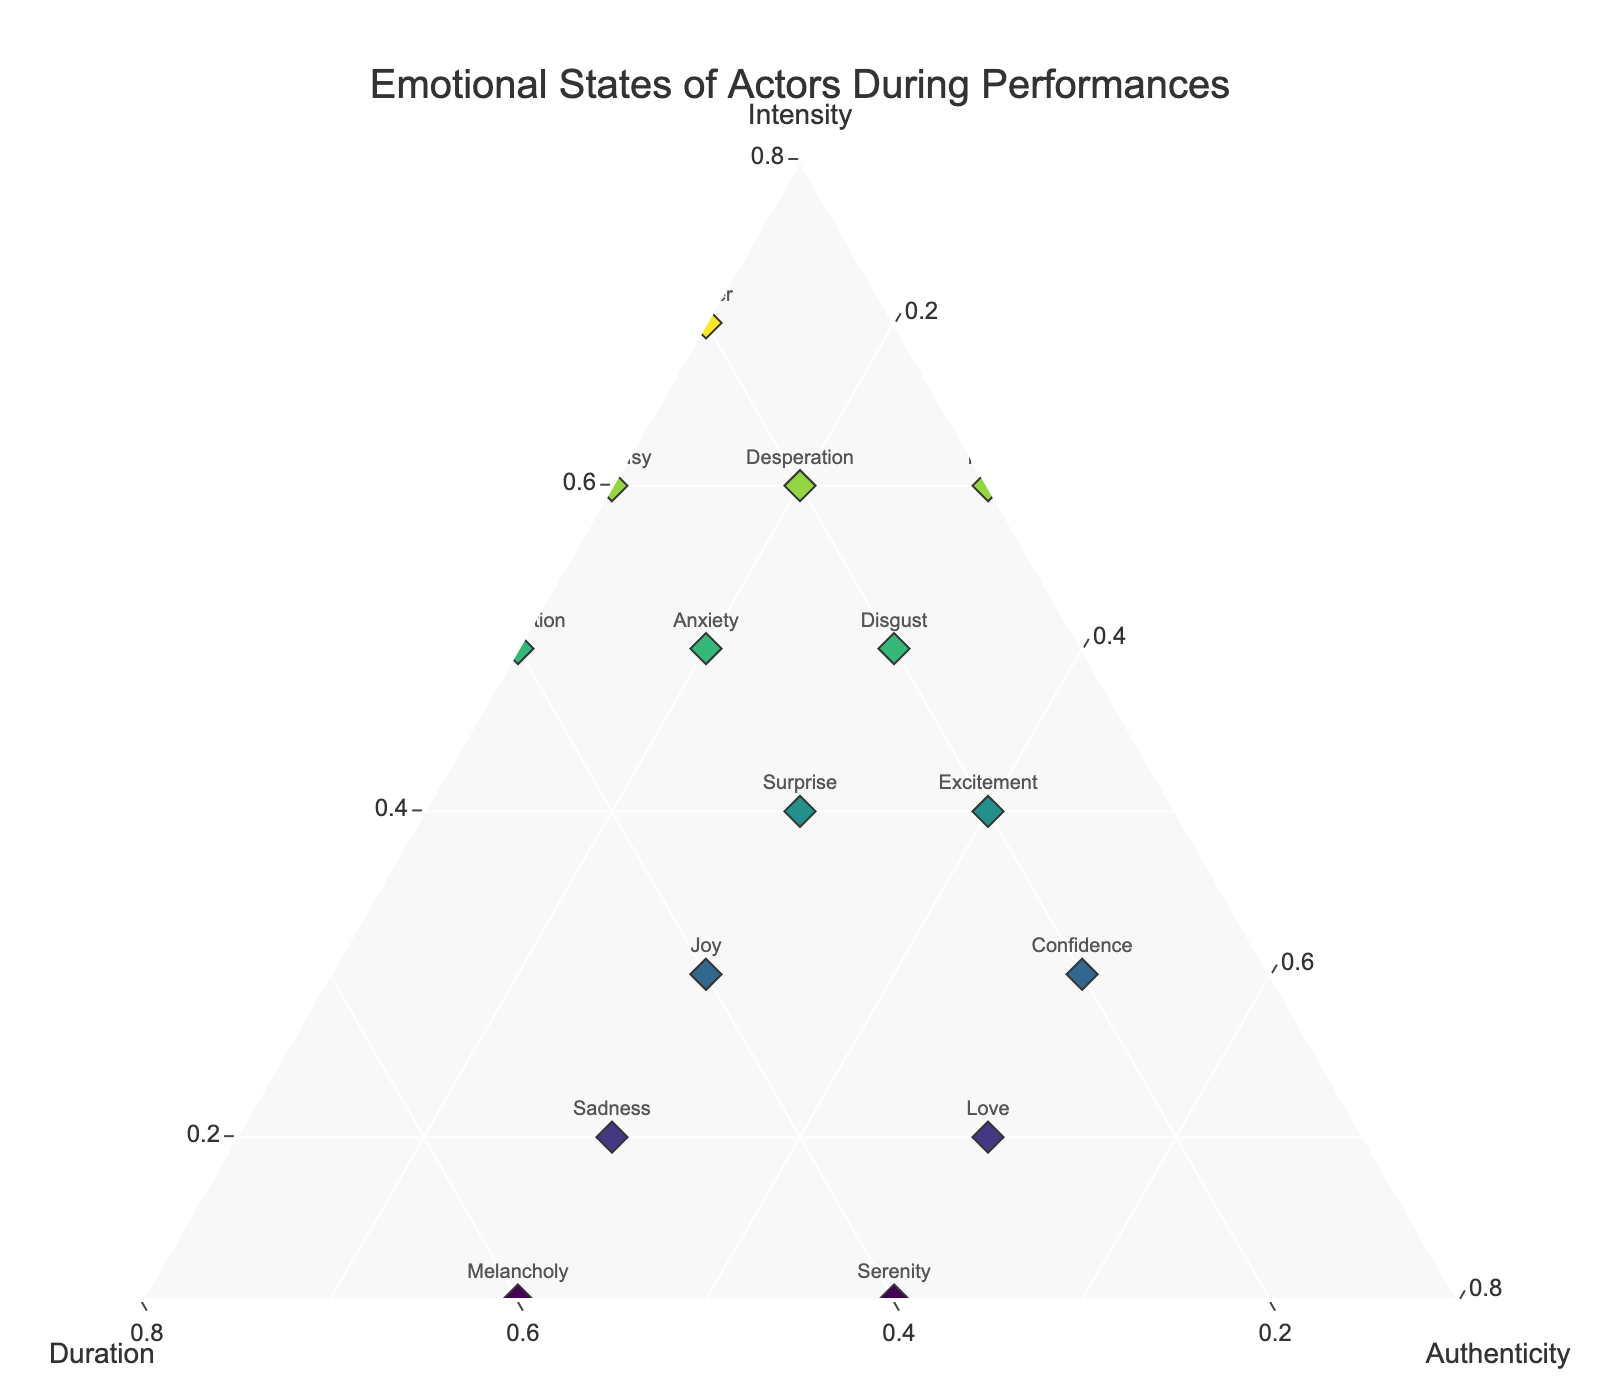What is the title of the plot? The plot's title is provided at the top of the figure. It helps summarize the visual information.
Answer: Emotional States of Actors During Performances How many emotional states are plotted in the figure? Count the number of unique emotions listed along with the scatter points.
Answer: 14 Which emotion has the highest intensity? Locate the point closest to the apex representing intensity and identify the associated emotion.
Answer: Anger Which emotional state has the highest authenticity? Find the point closest to the apex representing authenticity and note the corresponding emotion.
Answer: Love (and Serenity have equal highest authenticity) How does the intensity of Joy compare to the intensity of Sadness? Measure the distances of each point labeled 'Joy' and 'Sadness' from the intensity apex to see which is higher.
Answer: Joy has a higher intensity than Sadness What are the emotional states with an intensity value of 0.6? Identify the points on the intensity axis that correspond to 0.6 and read the associated emotions.
Answer: Fear, Jealousy, Desperation Which emotion has the longest duration? Determine the point closest to the apex representing duration and identify the associated emotion.
Answer: Melancholy Which emotions are equidistant from the duration axis? Find points symmetrically placed around the duration axis, indicating equal distance from it.
Answer: Joy, Serenity What is the most balanced emotional state in terms of all three components (intensity, duration, authenticity)? Find the point that is closest to the center of the ternary plot, indicating comparable values for all three components.
Answer: Surprise What emotion has an intensity of 0.5 and shows higher authenticity than duration? Find the point at 0.5 on the intensity axis and see which one has a greater value on the authenticity side compared to duration.
Answer: Confidence 